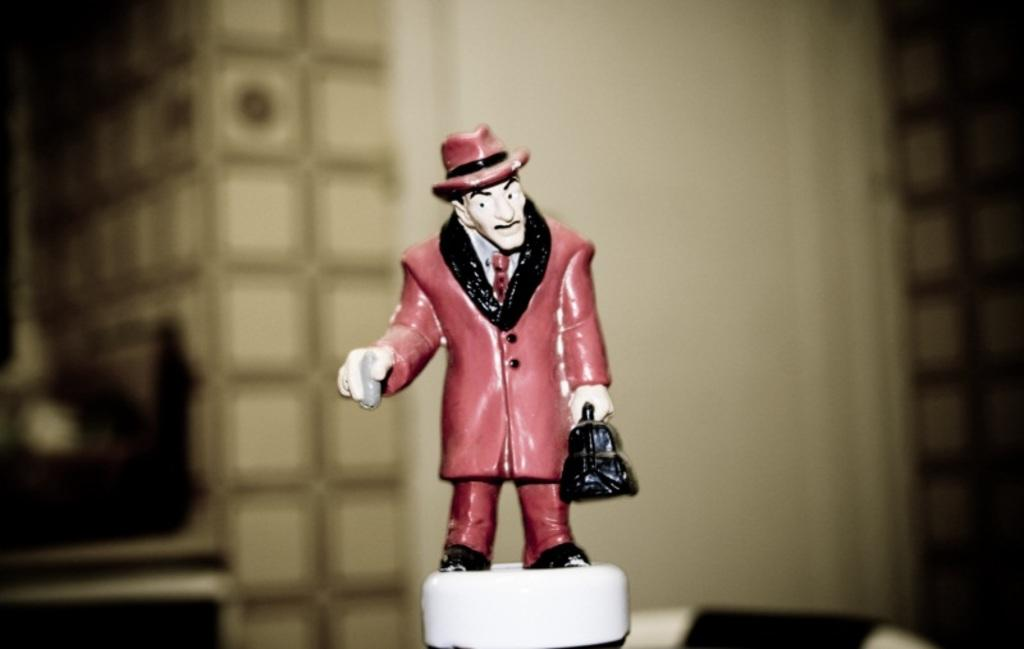What is the main subject of the image? The main subject of the image is a statue in the shape of a man. What type of clothing is the statue wearing? The statue is wearing a coat, trousers, and a hat. What type of plate is on the statue's head in the image? There is no plate present on the statue's head in the image. 